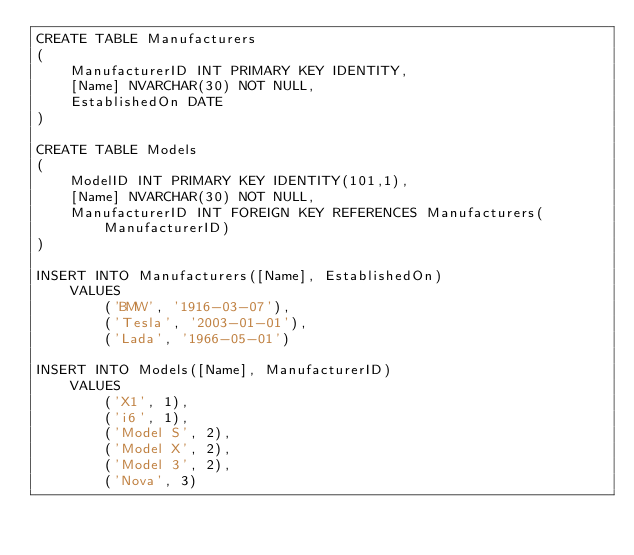<code> <loc_0><loc_0><loc_500><loc_500><_SQL_>CREATE TABLE Manufacturers
(
	ManufacturerID INT PRIMARY KEY IDENTITY,
	[Name] NVARCHAR(30) NOT NULL,
	EstablishedOn DATE
)

CREATE TABLE Models
(
	ModelID INT PRIMARY KEY IDENTITY(101,1),
	[Name] NVARCHAR(30) NOT NULL,
	ManufacturerID INT FOREIGN KEY REFERENCES Manufacturers(ManufacturerID)
)

INSERT INTO Manufacturers([Name], EstablishedOn)
	VALUES
		('BMW', '1916-03-07'),
		('Tesla', '2003-01-01'),
		('Lada', '1966-05-01')

INSERT INTO Models([Name], ManufacturerID)
	VALUES
		('X1', 1),
		('i6', 1),
		('Model S', 2),
		('Model X', 2),
		('Model 3', 2),
		('Nova', 3)</code> 